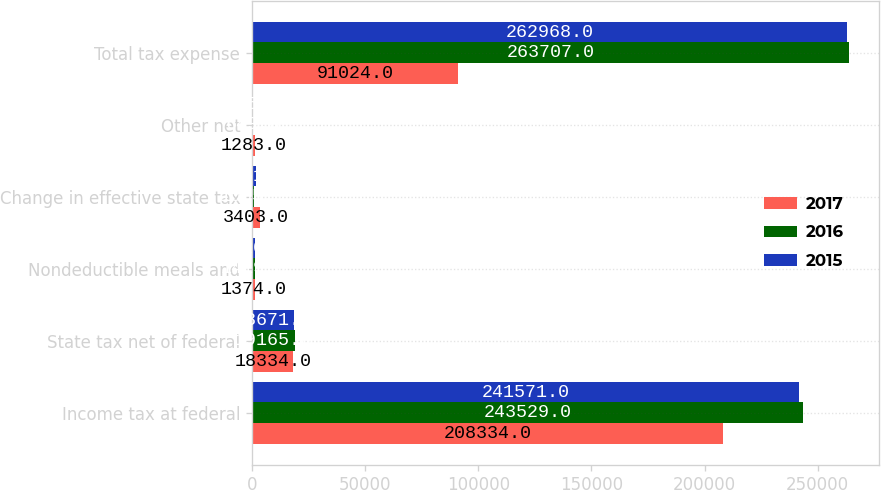<chart> <loc_0><loc_0><loc_500><loc_500><stacked_bar_chart><ecel><fcel>Income tax at federal<fcel>State tax net of federal<fcel>Nondeductible meals and<fcel>Change in effective state tax<fcel>Other net<fcel>Total tax expense<nl><fcel>2017<fcel>208334<fcel>18334<fcel>1374<fcel>3403<fcel>1283<fcel>91024<nl><fcel>2016<fcel>243529<fcel>19165<fcel>1419<fcel>1055<fcel>649<fcel>263707<nl><fcel>2015<fcel>241571<fcel>18671<fcel>1420<fcel>1761<fcel>455<fcel>262968<nl></chart> 